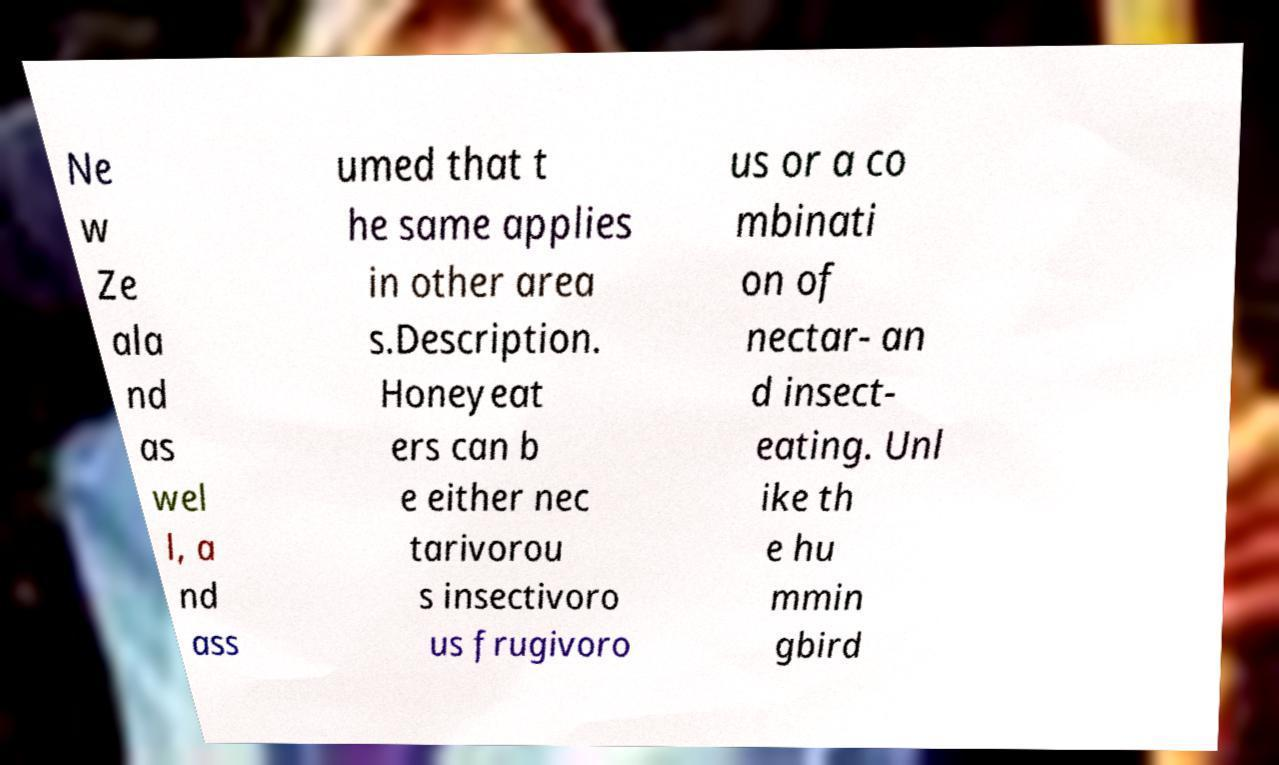Please read and relay the text visible in this image. What does it say? Ne w Ze ala nd as wel l, a nd ass umed that t he same applies in other area s.Description. Honeyeat ers can b e either nec tarivorou s insectivoro us frugivoro us or a co mbinati on of nectar- an d insect- eating. Unl ike th e hu mmin gbird 